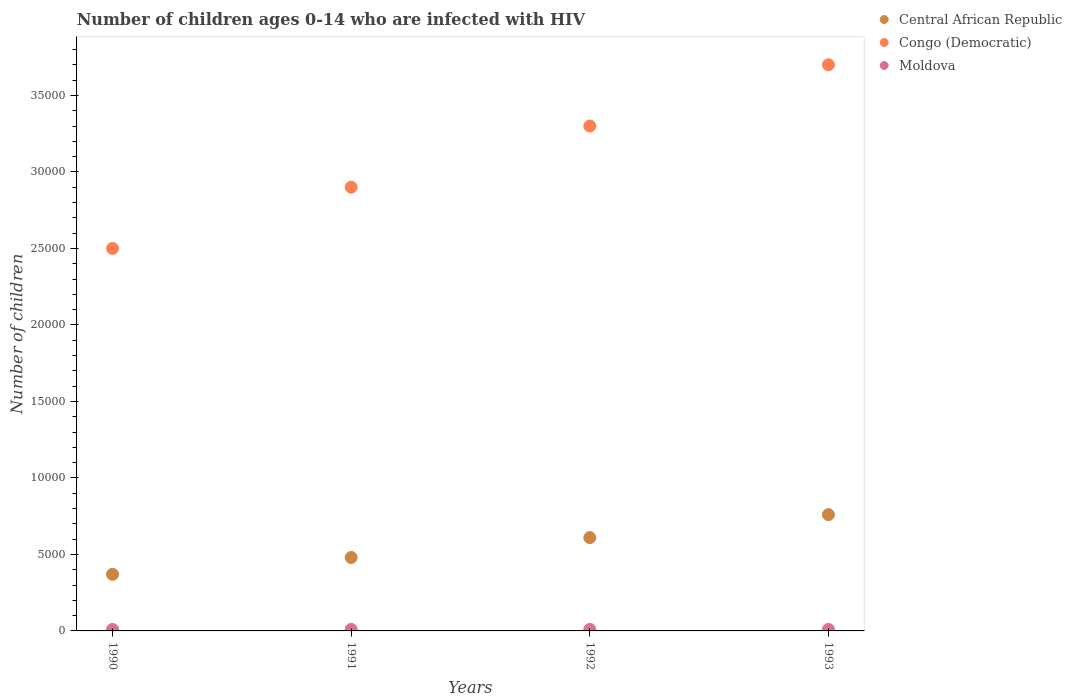How many different coloured dotlines are there?
Offer a very short reply. 3. Is the number of dotlines equal to the number of legend labels?
Offer a very short reply. Yes. What is the number of HIV infected children in Central African Republic in 1993?
Your answer should be compact. 7600. Across all years, what is the maximum number of HIV infected children in Central African Republic?
Offer a very short reply. 7600. Across all years, what is the minimum number of HIV infected children in Central African Republic?
Make the answer very short. 3700. What is the total number of HIV infected children in Central African Republic in the graph?
Provide a succinct answer. 2.22e+04. What is the difference between the number of HIV infected children in Central African Republic in 1991 and that in 1992?
Ensure brevity in your answer.  -1300. What is the difference between the number of HIV infected children in Moldova in 1993 and the number of HIV infected children in Central African Republic in 1990?
Ensure brevity in your answer.  -3600. What is the average number of HIV infected children in Moldova per year?
Make the answer very short. 100. In the year 1991, what is the difference between the number of HIV infected children in Central African Republic and number of HIV infected children in Congo (Democratic)?
Your answer should be very brief. -2.42e+04. What is the ratio of the number of HIV infected children in Central African Republic in 1990 to that in 1992?
Your answer should be compact. 0.61. Is the number of HIV infected children in Central African Republic in 1992 less than that in 1993?
Make the answer very short. Yes. Is the difference between the number of HIV infected children in Central African Republic in 1991 and 1992 greater than the difference between the number of HIV infected children in Congo (Democratic) in 1991 and 1992?
Provide a succinct answer. Yes. What is the difference between the highest and the second highest number of HIV infected children in Congo (Democratic)?
Offer a terse response. 4000. What is the difference between the highest and the lowest number of HIV infected children in Congo (Democratic)?
Your answer should be very brief. 1.20e+04. In how many years, is the number of HIV infected children in Moldova greater than the average number of HIV infected children in Moldova taken over all years?
Your answer should be compact. 0. Is the sum of the number of HIV infected children in Moldova in 1991 and 1992 greater than the maximum number of HIV infected children in Central African Republic across all years?
Your response must be concise. No. Does the number of HIV infected children in Moldova monotonically increase over the years?
Your response must be concise. No. Is the number of HIV infected children in Congo (Democratic) strictly less than the number of HIV infected children in Central African Republic over the years?
Provide a succinct answer. No. How many dotlines are there?
Provide a succinct answer. 3. How many years are there in the graph?
Your response must be concise. 4. Does the graph contain any zero values?
Provide a short and direct response. No. Does the graph contain grids?
Provide a short and direct response. No. Where does the legend appear in the graph?
Provide a succinct answer. Top right. How many legend labels are there?
Ensure brevity in your answer.  3. How are the legend labels stacked?
Make the answer very short. Vertical. What is the title of the graph?
Ensure brevity in your answer.  Number of children ages 0-14 who are infected with HIV. What is the label or title of the Y-axis?
Offer a very short reply. Number of children. What is the Number of children of Central African Republic in 1990?
Your response must be concise. 3700. What is the Number of children of Congo (Democratic) in 1990?
Your answer should be very brief. 2.50e+04. What is the Number of children of Moldova in 1990?
Offer a terse response. 100. What is the Number of children in Central African Republic in 1991?
Provide a succinct answer. 4800. What is the Number of children in Congo (Democratic) in 1991?
Ensure brevity in your answer.  2.90e+04. What is the Number of children of Moldova in 1991?
Make the answer very short. 100. What is the Number of children of Central African Republic in 1992?
Offer a terse response. 6100. What is the Number of children of Congo (Democratic) in 1992?
Keep it short and to the point. 3.30e+04. What is the Number of children of Central African Republic in 1993?
Provide a short and direct response. 7600. What is the Number of children of Congo (Democratic) in 1993?
Make the answer very short. 3.70e+04. Across all years, what is the maximum Number of children of Central African Republic?
Provide a succinct answer. 7600. Across all years, what is the maximum Number of children of Congo (Democratic)?
Your response must be concise. 3.70e+04. Across all years, what is the minimum Number of children of Central African Republic?
Your answer should be compact. 3700. Across all years, what is the minimum Number of children in Congo (Democratic)?
Your response must be concise. 2.50e+04. What is the total Number of children of Central African Republic in the graph?
Your answer should be very brief. 2.22e+04. What is the total Number of children in Congo (Democratic) in the graph?
Ensure brevity in your answer.  1.24e+05. What is the difference between the Number of children in Central African Republic in 1990 and that in 1991?
Make the answer very short. -1100. What is the difference between the Number of children of Congo (Democratic) in 1990 and that in 1991?
Your answer should be very brief. -4000. What is the difference between the Number of children in Moldova in 1990 and that in 1991?
Give a very brief answer. 0. What is the difference between the Number of children in Central African Republic in 1990 and that in 1992?
Make the answer very short. -2400. What is the difference between the Number of children of Congo (Democratic) in 1990 and that in 1992?
Your answer should be very brief. -8000. What is the difference between the Number of children in Central African Republic in 1990 and that in 1993?
Your answer should be compact. -3900. What is the difference between the Number of children of Congo (Democratic) in 1990 and that in 1993?
Your answer should be very brief. -1.20e+04. What is the difference between the Number of children of Central African Republic in 1991 and that in 1992?
Make the answer very short. -1300. What is the difference between the Number of children in Congo (Democratic) in 1991 and that in 1992?
Ensure brevity in your answer.  -4000. What is the difference between the Number of children of Central African Republic in 1991 and that in 1993?
Provide a short and direct response. -2800. What is the difference between the Number of children in Congo (Democratic) in 1991 and that in 1993?
Make the answer very short. -8000. What is the difference between the Number of children in Moldova in 1991 and that in 1993?
Offer a very short reply. 0. What is the difference between the Number of children in Central African Republic in 1992 and that in 1993?
Provide a short and direct response. -1500. What is the difference between the Number of children of Congo (Democratic) in 1992 and that in 1993?
Offer a very short reply. -4000. What is the difference between the Number of children of Central African Republic in 1990 and the Number of children of Congo (Democratic) in 1991?
Keep it short and to the point. -2.53e+04. What is the difference between the Number of children of Central African Republic in 1990 and the Number of children of Moldova in 1991?
Keep it short and to the point. 3600. What is the difference between the Number of children in Congo (Democratic) in 1990 and the Number of children in Moldova in 1991?
Your answer should be very brief. 2.49e+04. What is the difference between the Number of children in Central African Republic in 1990 and the Number of children in Congo (Democratic) in 1992?
Provide a succinct answer. -2.93e+04. What is the difference between the Number of children in Central African Republic in 1990 and the Number of children in Moldova in 1992?
Keep it short and to the point. 3600. What is the difference between the Number of children of Congo (Democratic) in 1990 and the Number of children of Moldova in 1992?
Your answer should be compact. 2.49e+04. What is the difference between the Number of children of Central African Republic in 1990 and the Number of children of Congo (Democratic) in 1993?
Keep it short and to the point. -3.33e+04. What is the difference between the Number of children of Central African Republic in 1990 and the Number of children of Moldova in 1993?
Offer a terse response. 3600. What is the difference between the Number of children in Congo (Democratic) in 1990 and the Number of children in Moldova in 1993?
Offer a terse response. 2.49e+04. What is the difference between the Number of children of Central African Republic in 1991 and the Number of children of Congo (Democratic) in 1992?
Your answer should be very brief. -2.82e+04. What is the difference between the Number of children in Central African Republic in 1991 and the Number of children in Moldova in 1992?
Make the answer very short. 4700. What is the difference between the Number of children in Congo (Democratic) in 1991 and the Number of children in Moldova in 1992?
Your response must be concise. 2.89e+04. What is the difference between the Number of children in Central African Republic in 1991 and the Number of children in Congo (Democratic) in 1993?
Keep it short and to the point. -3.22e+04. What is the difference between the Number of children in Central African Republic in 1991 and the Number of children in Moldova in 1993?
Your response must be concise. 4700. What is the difference between the Number of children of Congo (Democratic) in 1991 and the Number of children of Moldova in 1993?
Your answer should be compact. 2.89e+04. What is the difference between the Number of children of Central African Republic in 1992 and the Number of children of Congo (Democratic) in 1993?
Provide a short and direct response. -3.09e+04. What is the difference between the Number of children of Central African Republic in 1992 and the Number of children of Moldova in 1993?
Offer a very short reply. 6000. What is the difference between the Number of children of Congo (Democratic) in 1992 and the Number of children of Moldova in 1993?
Provide a short and direct response. 3.29e+04. What is the average Number of children in Central African Republic per year?
Make the answer very short. 5550. What is the average Number of children in Congo (Democratic) per year?
Provide a succinct answer. 3.10e+04. In the year 1990, what is the difference between the Number of children in Central African Republic and Number of children in Congo (Democratic)?
Your response must be concise. -2.13e+04. In the year 1990, what is the difference between the Number of children of Central African Republic and Number of children of Moldova?
Make the answer very short. 3600. In the year 1990, what is the difference between the Number of children of Congo (Democratic) and Number of children of Moldova?
Give a very brief answer. 2.49e+04. In the year 1991, what is the difference between the Number of children of Central African Republic and Number of children of Congo (Democratic)?
Offer a very short reply. -2.42e+04. In the year 1991, what is the difference between the Number of children of Central African Republic and Number of children of Moldova?
Make the answer very short. 4700. In the year 1991, what is the difference between the Number of children in Congo (Democratic) and Number of children in Moldova?
Provide a succinct answer. 2.89e+04. In the year 1992, what is the difference between the Number of children in Central African Republic and Number of children in Congo (Democratic)?
Ensure brevity in your answer.  -2.69e+04. In the year 1992, what is the difference between the Number of children of Central African Republic and Number of children of Moldova?
Provide a succinct answer. 6000. In the year 1992, what is the difference between the Number of children of Congo (Democratic) and Number of children of Moldova?
Your answer should be compact. 3.29e+04. In the year 1993, what is the difference between the Number of children of Central African Republic and Number of children of Congo (Democratic)?
Make the answer very short. -2.94e+04. In the year 1993, what is the difference between the Number of children in Central African Republic and Number of children in Moldova?
Provide a succinct answer. 7500. In the year 1993, what is the difference between the Number of children in Congo (Democratic) and Number of children in Moldova?
Keep it short and to the point. 3.69e+04. What is the ratio of the Number of children in Central African Republic in 1990 to that in 1991?
Offer a very short reply. 0.77. What is the ratio of the Number of children of Congo (Democratic) in 1990 to that in 1991?
Keep it short and to the point. 0.86. What is the ratio of the Number of children of Central African Republic in 1990 to that in 1992?
Keep it short and to the point. 0.61. What is the ratio of the Number of children in Congo (Democratic) in 1990 to that in 1992?
Your answer should be very brief. 0.76. What is the ratio of the Number of children in Central African Republic in 1990 to that in 1993?
Offer a very short reply. 0.49. What is the ratio of the Number of children in Congo (Democratic) in 1990 to that in 1993?
Ensure brevity in your answer.  0.68. What is the ratio of the Number of children of Central African Republic in 1991 to that in 1992?
Your answer should be compact. 0.79. What is the ratio of the Number of children of Congo (Democratic) in 1991 to that in 1992?
Your answer should be compact. 0.88. What is the ratio of the Number of children of Central African Republic in 1991 to that in 1993?
Keep it short and to the point. 0.63. What is the ratio of the Number of children in Congo (Democratic) in 1991 to that in 1993?
Ensure brevity in your answer.  0.78. What is the ratio of the Number of children of Moldova in 1991 to that in 1993?
Make the answer very short. 1. What is the ratio of the Number of children in Central African Republic in 1992 to that in 1993?
Your response must be concise. 0.8. What is the ratio of the Number of children of Congo (Democratic) in 1992 to that in 1993?
Offer a terse response. 0.89. What is the ratio of the Number of children in Moldova in 1992 to that in 1993?
Provide a short and direct response. 1. What is the difference between the highest and the second highest Number of children in Central African Republic?
Offer a very short reply. 1500. What is the difference between the highest and the second highest Number of children in Congo (Democratic)?
Offer a very short reply. 4000. What is the difference between the highest and the lowest Number of children in Central African Republic?
Give a very brief answer. 3900. What is the difference between the highest and the lowest Number of children in Congo (Democratic)?
Provide a short and direct response. 1.20e+04. 